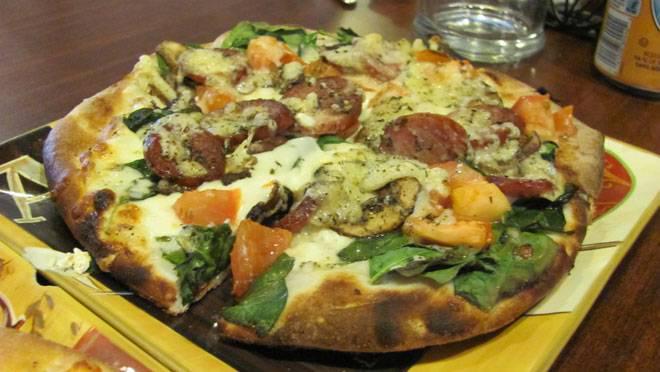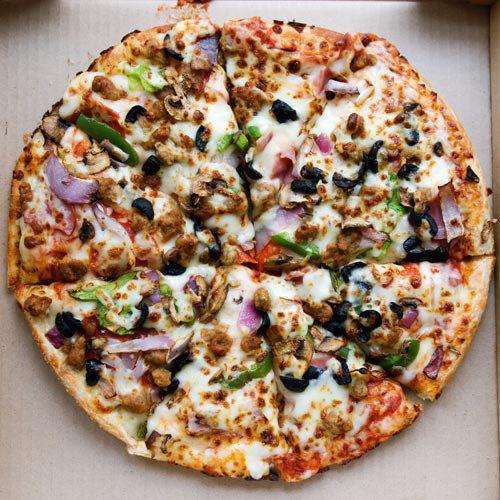The first image is the image on the left, the second image is the image on the right. Given the left and right images, does the statement "The left image features an uncut square pizza, and the right image contains at least part of a sliced round pizza." hold true? Answer yes or no. No. The first image is the image on the left, the second image is the image on the right. For the images displayed, is the sentence "There is one round pizza in each image." factually correct? Answer yes or no. Yes. 